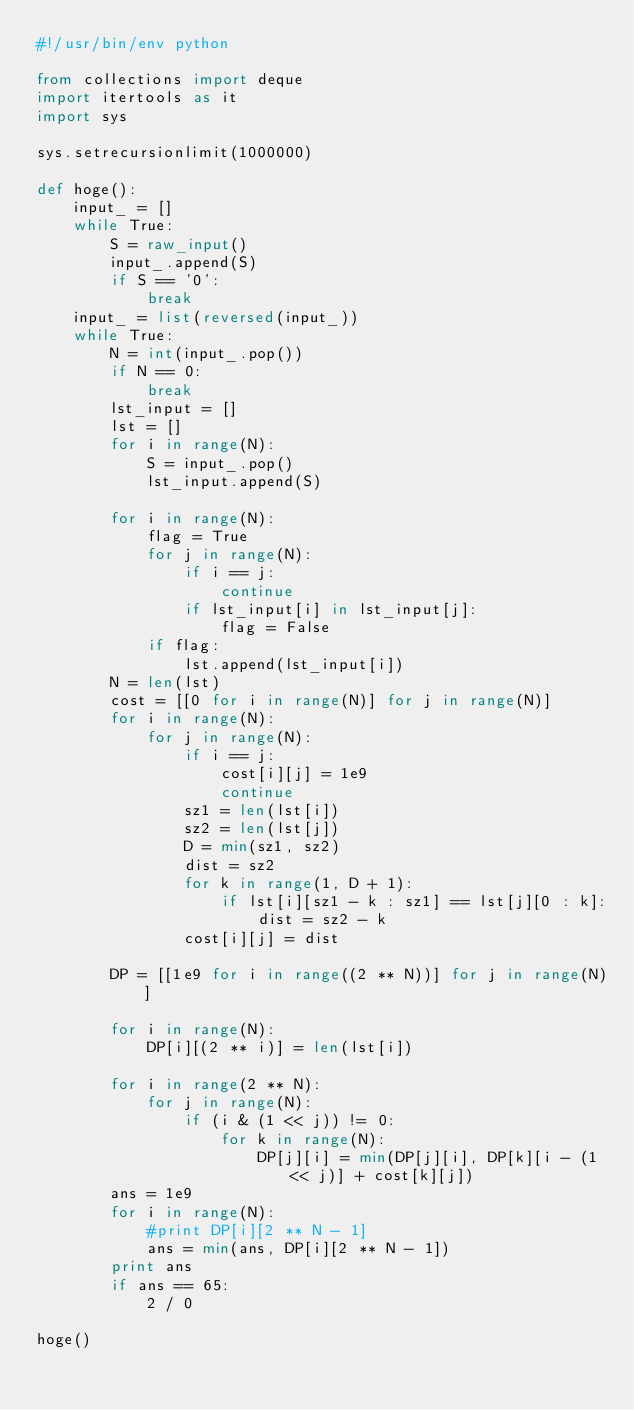<code> <loc_0><loc_0><loc_500><loc_500><_Python_>#!/usr/bin/env python

from collections import deque
import itertools as it
import sys

sys.setrecursionlimit(1000000)

def hoge():
    input_ = []
    while True:
        S = raw_input()
        input_.append(S)
        if S == '0':
            break
    input_ = list(reversed(input_))
    while True:
        N = int(input_.pop())
        if N == 0:
            break
        lst_input = []
        lst = []
        for i in range(N):
            S = input_.pop()
            lst_input.append(S)
        
        for i in range(N):
            flag = True
            for j in range(N):
                if i == j:
                    continue
                if lst_input[i] in lst_input[j]:
                    flag = False
            if flag:
                lst.append(lst_input[i])
        N = len(lst)
        cost = [[0 for i in range(N)] for j in range(N)]
        for i in range(N):
            for j in range(N):
                if i == j:
                    cost[i][j] = 1e9
                    continue
                sz1 = len(lst[i])
                sz2 = len(lst[j])
                D = min(sz1, sz2)
                dist = sz2
                for k in range(1, D + 1):
                    if lst[i][sz1 - k : sz1] == lst[j][0 : k]:
                        dist = sz2 - k
                cost[i][j] = dist
        
        DP = [[1e9 for i in range((2 ** N))] for j in range(N)]

        for i in range(N):
            DP[i][(2 ** i)] = len(lst[i])
        
        for i in range(2 ** N):
            for j in range(N):
                if (i & (1 << j)) != 0:
                    for k in range(N):
                        DP[j][i] = min(DP[j][i], DP[k][i - (1 << j)] + cost[k][j])
        ans = 1e9
        for i in range(N):
            #print DP[i][2 ** N - 1]
            ans = min(ans, DP[i][2 ** N - 1])
        print ans
        if ans == 65:
            2 / 0

hoge()
</code> 